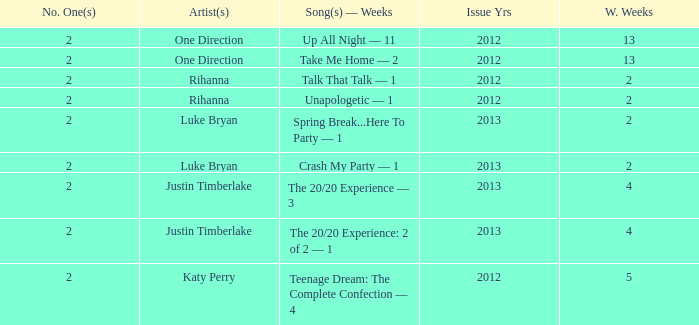What is the title of every song, and how many weeks was each song at #1 for Rihanna in 2012? Talk That Talk — 1, Unapologetic — 1. 